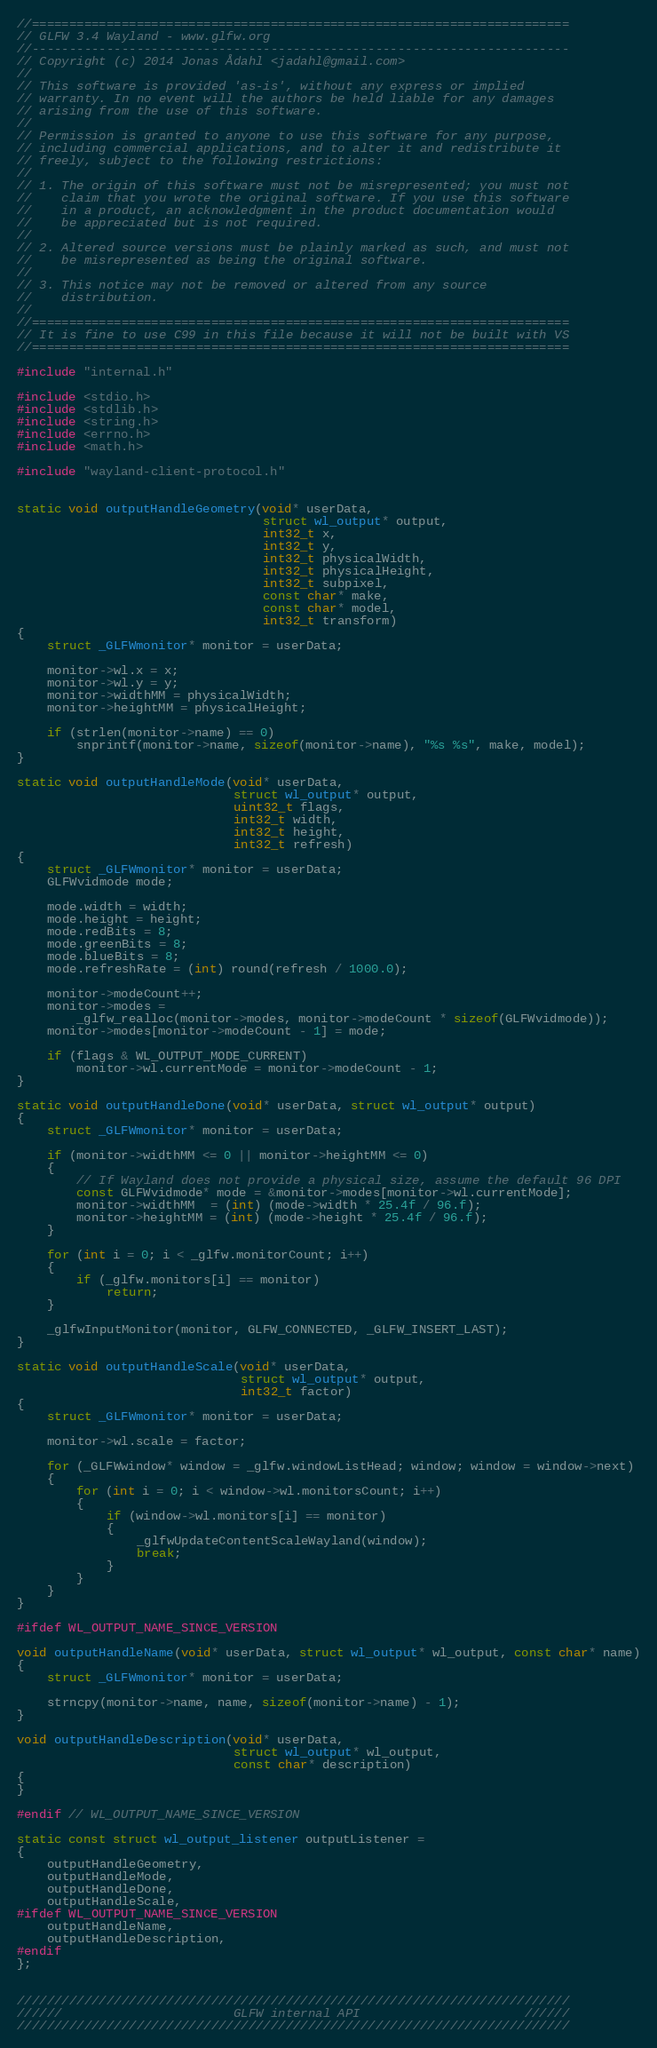<code> <loc_0><loc_0><loc_500><loc_500><_C_>//========================================================================
// GLFW 3.4 Wayland - www.glfw.org
//------------------------------------------------------------------------
// Copyright (c) 2014 Jonas Ådahl <jadahl@gmail.com>
//
// This software is provided 'as-is', without any express or implied
// warranty. In no event will the authors be held liable for any damages
// arising from the use of this software.
//
// Permission is granted to anyone to use this software for any purpose,
// including commercial applications, and to alter it and redistribute it
// freely, subject to the following restrictions:
//
// 1. The origin of this software must not be misrepresented; you must not
//    claim that you wrote the original software. If you use this software
//    in a product, an acknowledgment in the product documentation would
//    be appreciated but is not required.
//
// 2. Altered source versions must be plainly marked as such, and must not
//    be misrepresented as being the original software.
//
// 3. This notice may not be removed or altered from any source
//    distribution.
//
//========================================================================
// It is fine to use C99 in this file because it will not be built with VS
//========================================================================

#include "internal.h"

#include <stdio.h>
#include <stdlib.h>
#include <string.h>
#include <errno.h>
#include <math.h>

#include "wayland-client-protocol.h"


static void outputHandleGeometry(void* userData,
                                 struct wl_output* output,
                                 int32_t x,
                                 int32_t y,
                                 int32_t physicalWidth,
                                 int32_t physicalHeight,
                                 int32_t subpixel,
                                 const char* make,
                                 const char* model,
                                 int32_t transform)
{
    struct _GLFWmonitor* monitor = userData;

    monitor->wl.x = x;
    monitor->wl.y = y;
    monitor->widthMM = physicalWidth;
    monitor->heightMM = physicalHeight;

    if (strlen(monitor->name) == 0)
        snprintf(monitor->name, sizeof(monitor->name), "%s %s", make, model);
}

static void outputHandleMode(void* userData,
                             struct wl_output* output,
                             uint32_t flags,
                             int32_t width,
                             int32_t height,
                             int32_t refresh)
{
    struct _GLFWmonitor* monitor = userData;
    GLFWvidmode mode;

    mode.width = width;
    mode.height = height;
    mode.redBits = 8;
    mode.greenBits = 8;
    mode.blueBits = 8;
    mode.refreshRate = (int) round(refresh / 1000.0);

    monitor->modeCount++;
    monitor->modes =
        _glfw_realloc(monitor->modes, monitor->modeCount * sizeof(GLFWvidmode));
    monitor->modes[monitor->modeCount - 1] = mode;

    if (flags & WL_OUTPUT_MODE_CURRENT)
        monitor->wl.currentMode = monitor->modeCount - 1;
}

static void outputHandleDone(void* userData, struct wl_output* output)
{
    struct _GLFWmonitor* monitor = userData;

    if (monitor->widthMM <= 0 || monitor->heightMM <= 0)
    {
        // If Wayland does not provide a physical size, assume the default 96 DPI
        const GLFWvidmode* mode = &monitor->modes[monitor->wl.currentMode];
        monitor->widthMM  = (int) (mode->width * 25.4f / 96.f);
        monitor->heightMM = (int) (mode->height * 25.4f / 96.f);
    }

    for (int i = 0; i < _glfw.monitorCount; i++)
    {
        if (_glfw.monitors[i] == monitor)
            return;
    }

    _glfwInputMonitor(monitor, GLFW_CONNECTED, _GLFW_INSERT_LAST);
}

static void outputHandleScale(void* userData,
                              struct wl_output* output,
                              int32_t factor)
{
    struct _GLFWmonitor* monitor = userData;

    monitor->wl.scale = factor;

    for (_GLFWwindow* window = _glfw.windowListHead; window; window = window->next)
    {
        for (int i = 0; i < window->wl.monitorsCount; i++)
        {
            if (window->wl.monitors[i] == monitor)
            {
                _glfwUpdateContentScaleWayland(window);
                break;
            }
        }
    }
}

#ifdef WL_OUTPUT_NAME_SINCE_VERSION

void outputHandleName(void* userData, struct wl_output* wl_output, const char* name)
{
    struct _GLFWmonitor* monitor = userData;

    strncpy(monitor->name, name, sizeof(monitor->name) - 1);
}

void outputHandleDescription(void* userData,
                             struct wl_output* wl_output,
                             const char* description)
{
}

#endif // WL_OUTPUT_NAME_SINCE_VERSION

static const struct wl_output_listener outputListener =
{
    outputHandleGeometry,
    outputHandleMode,
    outputHandleDone,
    outputHandleScale,
#ifdef WL_OUTPUT_NAME_SINCE_VERSION
    outputHandleName,
    outputHandleDescription,
#endif
};


//////////////////////////////////////////////////////////////////////////
//////                       GLFW internal API                      //////
//////////////////////////////////////////////////////////////////////////
</code> 